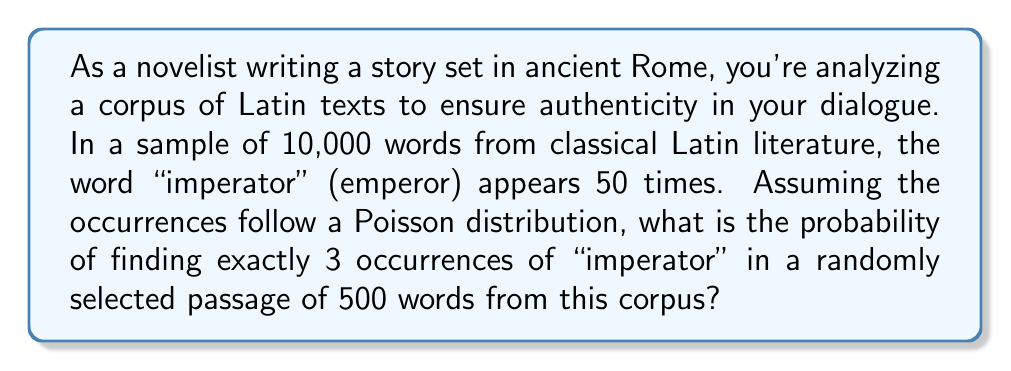Can you solve this math problem? Let's approach this step-by-step:

1) First, we need to calculate the rate (λ) at which "imperator" appears in the corpus:
   
   λ = (50 occurrences / 10,000 words) × 500 words = 2.5

2) We're using a Poisson distribution because we're dealing with rare events (word occurrences) in a large sample space.

3) The Poisson probability mass function is:

   $$P(X = k) = \frac{e^{-λ} λ^k}{k!}$$

   where k is the number of occurrences we're interested in (3 in this case).

4) Substituting our values:

   $$P(X = 3) = \frac{e^{-2.5} 2.5^3}{3!}$$

5) Let's calculate this step-by-step:
   
   $$P(X = 3) = \frac{e^{-2.5} × 15.625}{6}$$
   
   $$= \frac{0.082085 × 15.625}{6}$$
   
   $$= \frac{1.282578}{6}$$
   
   $$= 0.213763$$

6) Therefore, the probability is approximately 0.2138 or 21.38%.
Answer: 0.2138 